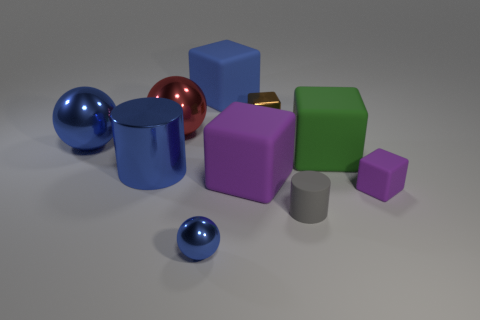What number of things are either blue things that are right of the metallic cylinder or small metallic objects?
Offer a very short reply. 3. There is a gray rubber thing that is the same size as the brown thing; what is its shape?
Ensure brevity in your answer.  Cylinder. There is a matte block behind the brown block; is it the same size as the blue shiny sphere that is to the right of the red metal ball?
Offer a terse response. No. What color is the tiny cube that is the same material as the small blue object?
Make the answer very short. Brown. Is the material of the block that is in front of the big purple matte object the same as the purple object to the left of the green cube?
Your response must be concise. Yes. Is there a purple shiny block of the same size as the blue block?
Offer a very short reply. No. There is a blue metallic object in front of the small cube that is in front of the tiny brown block; what size is it?
Provide a short and direct response. Small. How many big things have the same color as the shiny cylinder?
Your response must be concise. 2. What is the shape of the thing behind the tiny metal object that is behind the large purple cube?
Keep it short and to the point. Cube. What number of other purple cubes are made of the same material as the large purple block?
Your answer should be very brief. 1. 